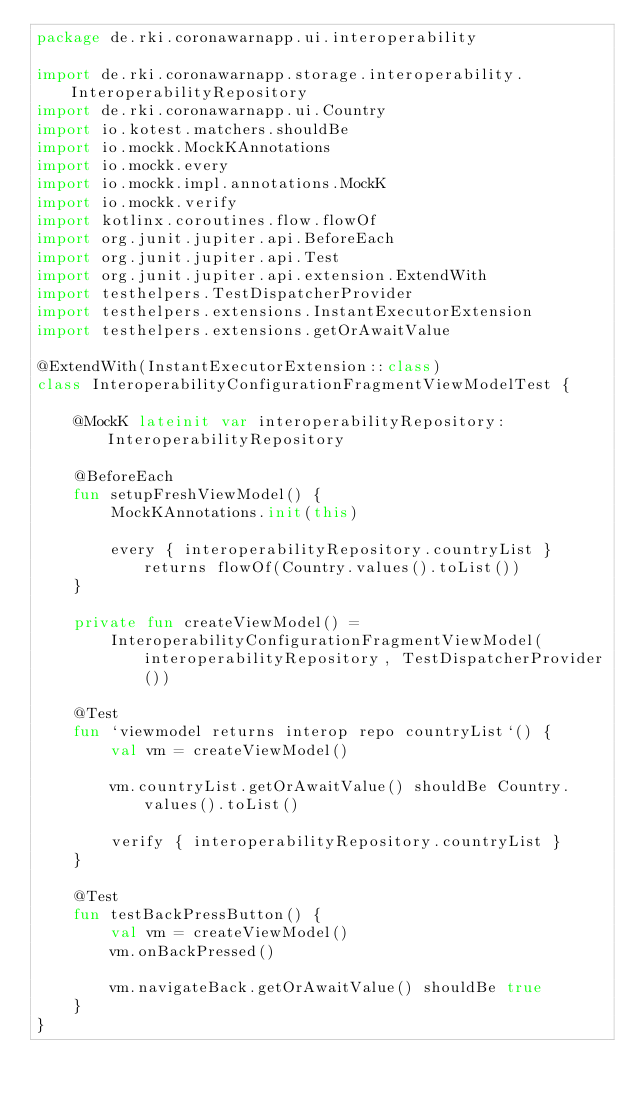Convert code to text. <code><loc_0><loc_0><loc_500><loc_500><_Kotlin_>package de.rki.coronawarnapp.ui.interoperability

import de.rki.coronawarnapp.storage.interoperability.InteroperabilityRepository
import de.rki.coronawarnapp.ui.Country
import io.kotest.matchers.shouldBe
import io.mockk.MockKAnnotations
import io.mockk.every
import io.mockk.impl.annotations.MockK
import io.mockk.verify
import kotlinx.coroutines.flow.flowOf
import org.junit.jupiter.api.BeforeEach
import org.junit.jupiter.api.Test
import org.junit.jupiter.api.extension.ExtendWith
import testhelpers.TestDispatcherProvider
import testhelpers.extensions.InstantExecutorExtension
import testhelpers.extensions.getOrAwaitValue

@ExtendWith(InstantExecutorExtension::class)
class InteroperabilityConfigurationFragmentViewModelTest {

    @MockK lateinit var interoperabilityRepository: InteroperabilityRepository

    @BeforeEach
    fun setupFreshViewModel() {
        MockKAnnotations.init(this)

        every { interoperabilityRepository.countryList } returns flowOf(Country.values().toList())
    }

    private fun createViewModel() =
        InteroperabilityConfigurationFragmentViewModel(interoperabilityRepository, TestDispatcherProvider())

    @Test
    fun `viewmodel returns interop repo countryList`() {
        val vm = createViewModel()

        vm.countryList.getOrAwaitValue() shouldBe Country.values().toList()

        verify { interoperabilityRepository.countryList }
    }

    @Test
    fun testBackPressButton() {
        val vm = createViewModel()
        vm.onBackPressed()

        vm.navigateBack.getOrAwaitValue() shouldBe true
    }
}
</code> 